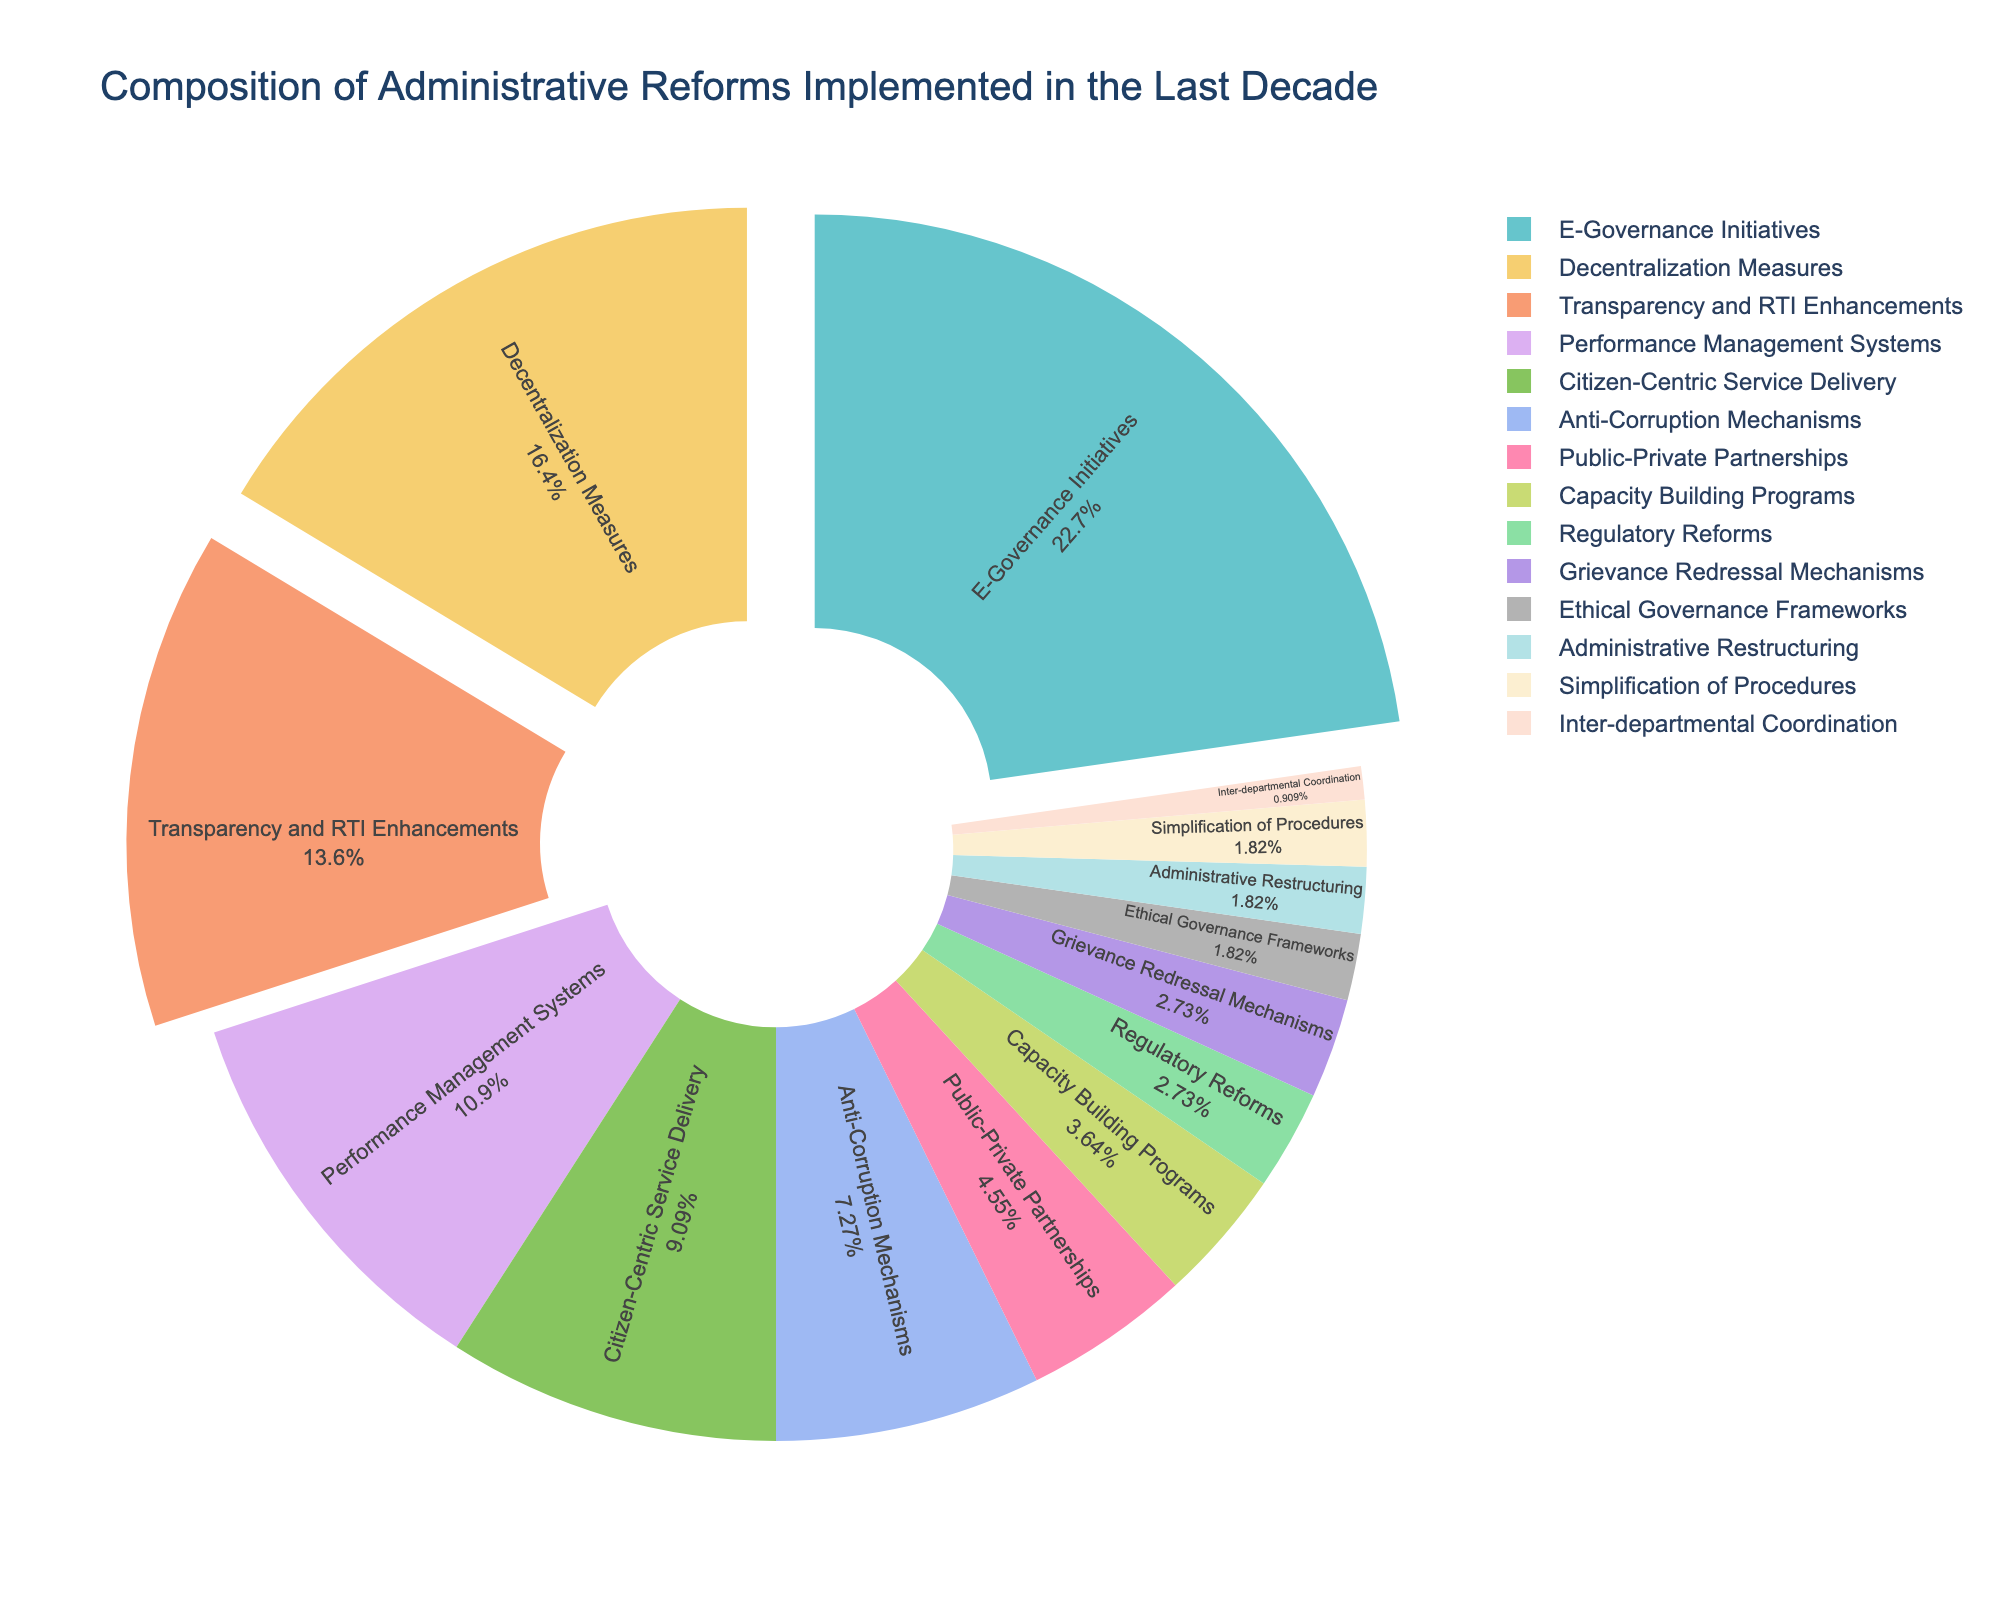Which category has the highest percentage in the composition of administrative reforms? By observing the pie chart, we can see that the section labeled "E-Governance Initiatives" is the largest, indicating it has the highest percentage.
Answer: E-Governance Initiatives What is the combined percentage of Decentralization Measures and Transparency and RTI Enhancements? From the pie chart, Decentralization Measures is 18% and Transparency and RTI Enhancements is 15%. Adding these together, we get 18% + 15% = 33%.
Answer: 33% How does the percentage of Regulatory Reforms compare to Grievance Redressal Mechanisms? By looking at the pie chart, both Regulatory Reforms and Grievance Redressal Mechanisms are represented by small sections. According to the data, both have an equal percentage of 3%.
Answer: Equal Which three categories have the smallest percentages, and what are their combined total? Observing the smallest sections of the pie chart, we identify Inter-departmental Coordination (1%), Ethical Governance Frameworks (2%), and Administrative Restructuring (2%). Their combined total is 1% + 2% + 2% = 5%.
Answer: Inter-departmental Coordination, Ethical Governance Frameworks, Administrative Restructuring; 5% If Citizen-Centric Service Delivery and Anti-Corruption Mechanisms were combined, would their total percentage be more than Decentralization Measures? Citizen-Centric Service Delivery is 10% and Anti-Corruption Mechanisms is 8%. Combining them would be 10% + 8% = 18%. Decentralization Measures alone is 18%, so combined they are equal.
Answer: Equal to Decentralization Measures What is the difference between the highest and lowest percentages among the categories? The highest percentage is E-Governance Initiatives at 25%, and the lowest is Inter-departmental Coordination at 1%. The difference is 25% - 1% = 24%.
Answer: 24% Which category contributes 5% to the composition of administrative reforms? From the pie chart, we can observe that Public-Private Partnerships is the category that contributes 5%.
Answer: Public-Private Partnerships How many categories have a percentage that is less than or equal to 5%? Observing the pie chart, we see that Public-Private Partnerships (5%), Capacity Building Programs (4%), Regulatory Reforms (3%), Grievance Redressal Mechanisms (3%), Ethical Governance Frameworks (2%), Administrative Restructuring (2%), and Inter-departmental Coordination (1%) fall into this range. This totals to seven categories.
Answer: Seven 